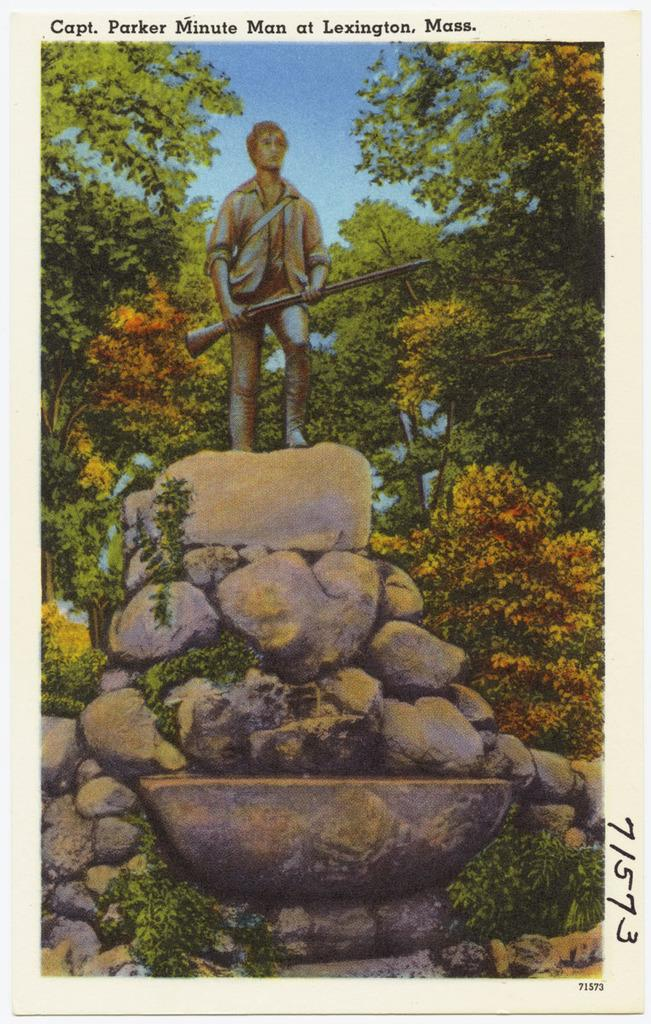What is the main subject of the image? There is a man standing in the image. What is the man standing on? The man is standing on stones. What type of natural elements can be seen in the image? There are trees in the image. What type of stone is the man using to play chess in the image? There is no chess game or stone present in the image; it only features a man standing on stones and trees in the background. 